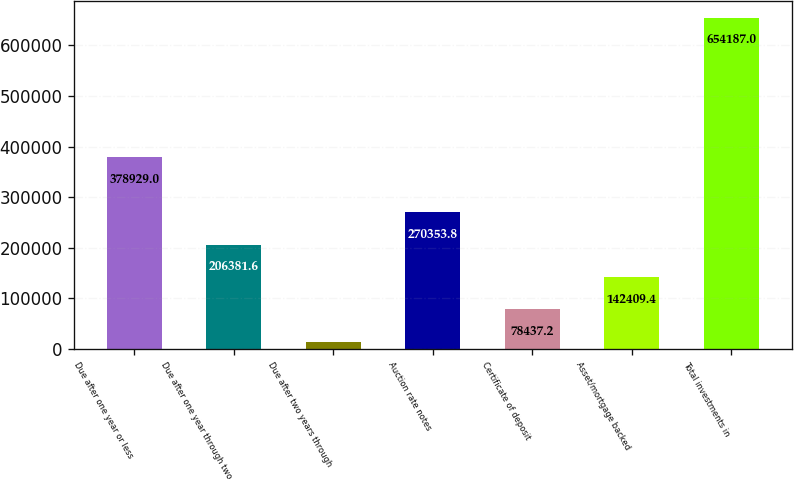Convert chart. <chart><loc_0><loc_0><loc_500><loc_500><bar_chart><fcel>Due after one year or less<fcel>Due after one year through two<fcel>Due after two years through<fcel>Auction rate notes<fcel>Certificate of deposit<fcel>Asset/mortgage backed<fcel>Total investments in<nl><fcel>378929<fcel>206382<fcel>14465<fcel>270354<fcel>78437.2<fcel>142409<fcel>654187<nl></chart> 